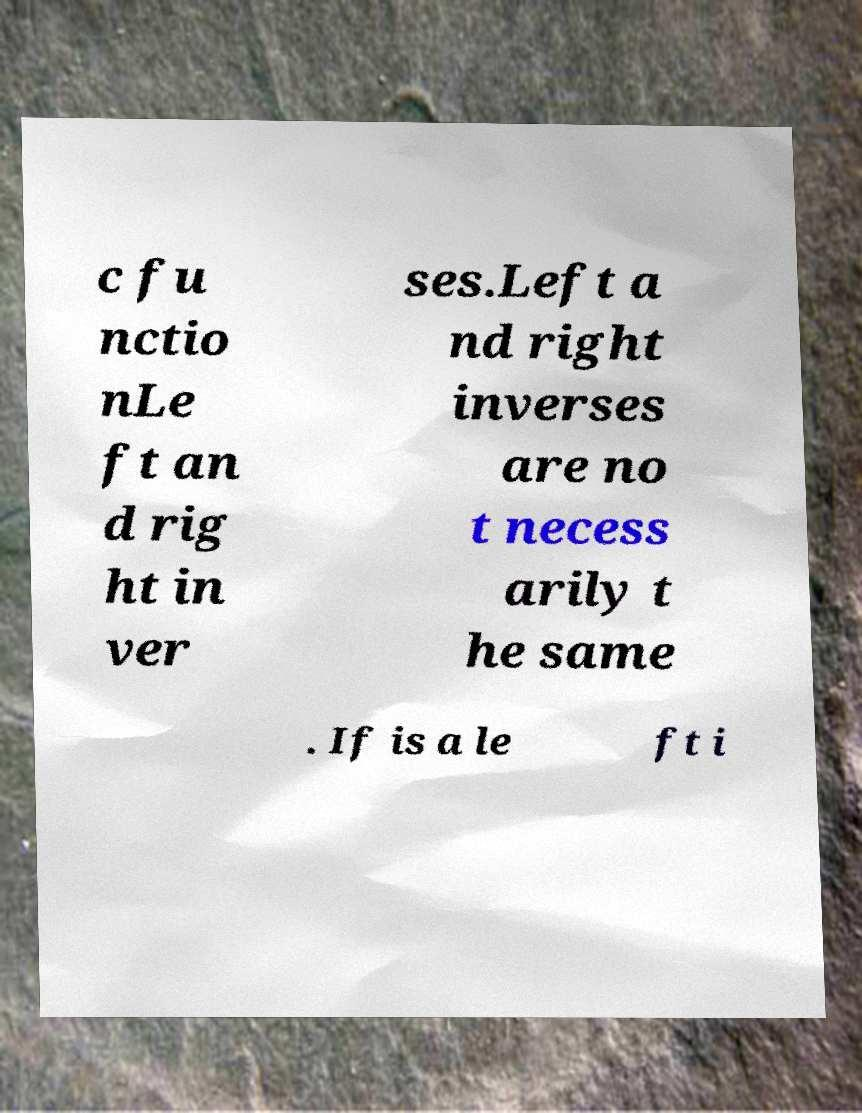For documentation purposes, I need the text within this image transcribed. Could you provide that? c fu nctio nLe ft an d rig ht in ver ses.Left a nd right inverses are no t necess arily t he same . If is a le ft i 